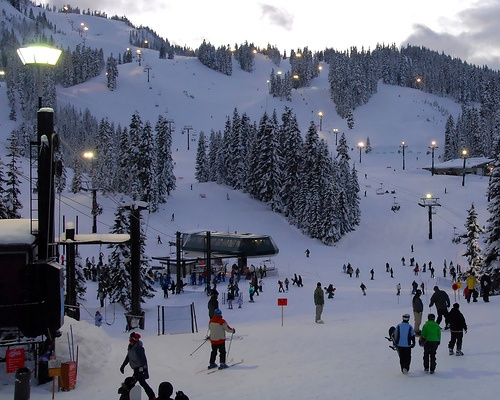Describe the objects in this image and their specific colors. I can see people in gray and black tones, people in gray, black, and darkgray tones, people in gray, black, and darkgreen tones, people in gray, black, blue, darkblue, and darkgray tones, and people in gray, black, maroon, and darkgray tones in this image. 